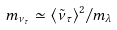<formula> <loc_0><loc_0><loc_500><loc_500>m _ { \nu _ { \tau } } \simeq { \langle \tilde { \nu } _ { \tau } \rangle ^ { 2 } } / m _ { \lambda }</formula> 